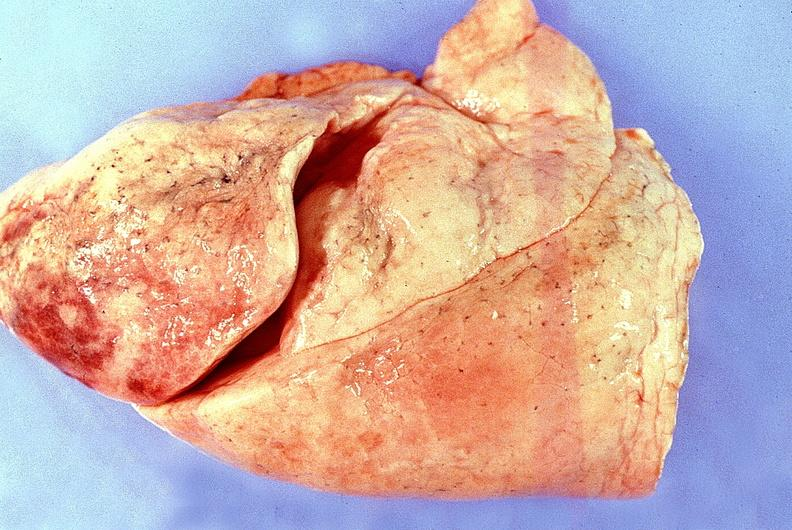what is present?
Answer the question using a single word or phrase. Respiratory 